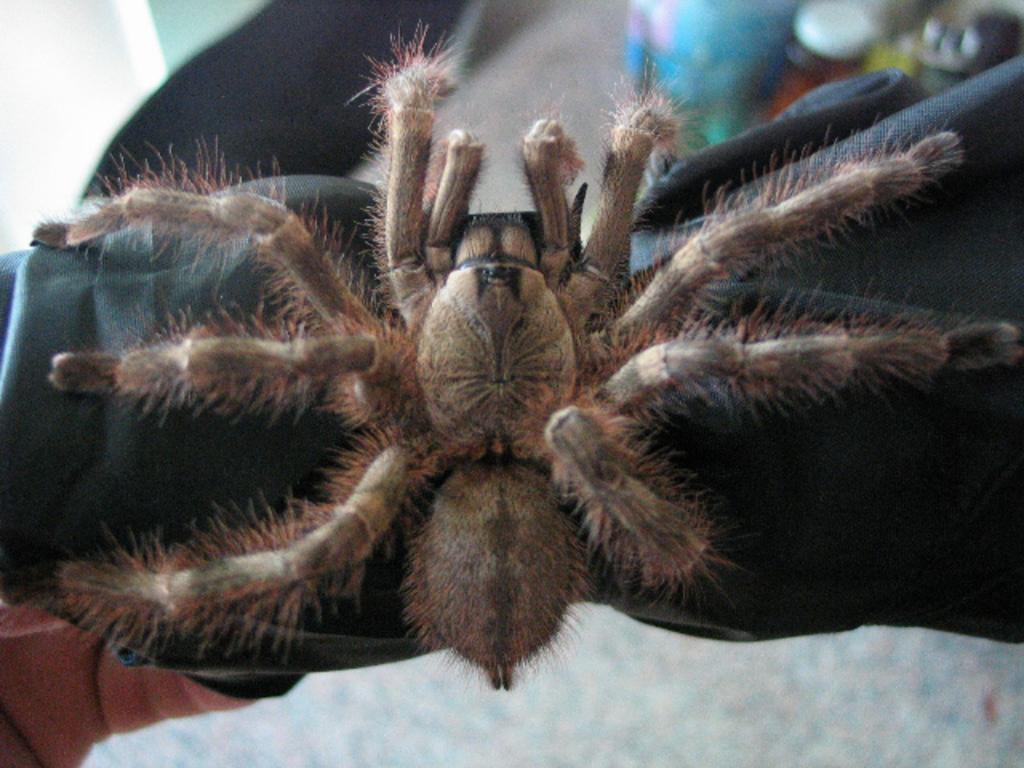Could you give a brief overview of what you see in this image? In this image we can see a spider on a surface. In the background, we can see a bottle. 